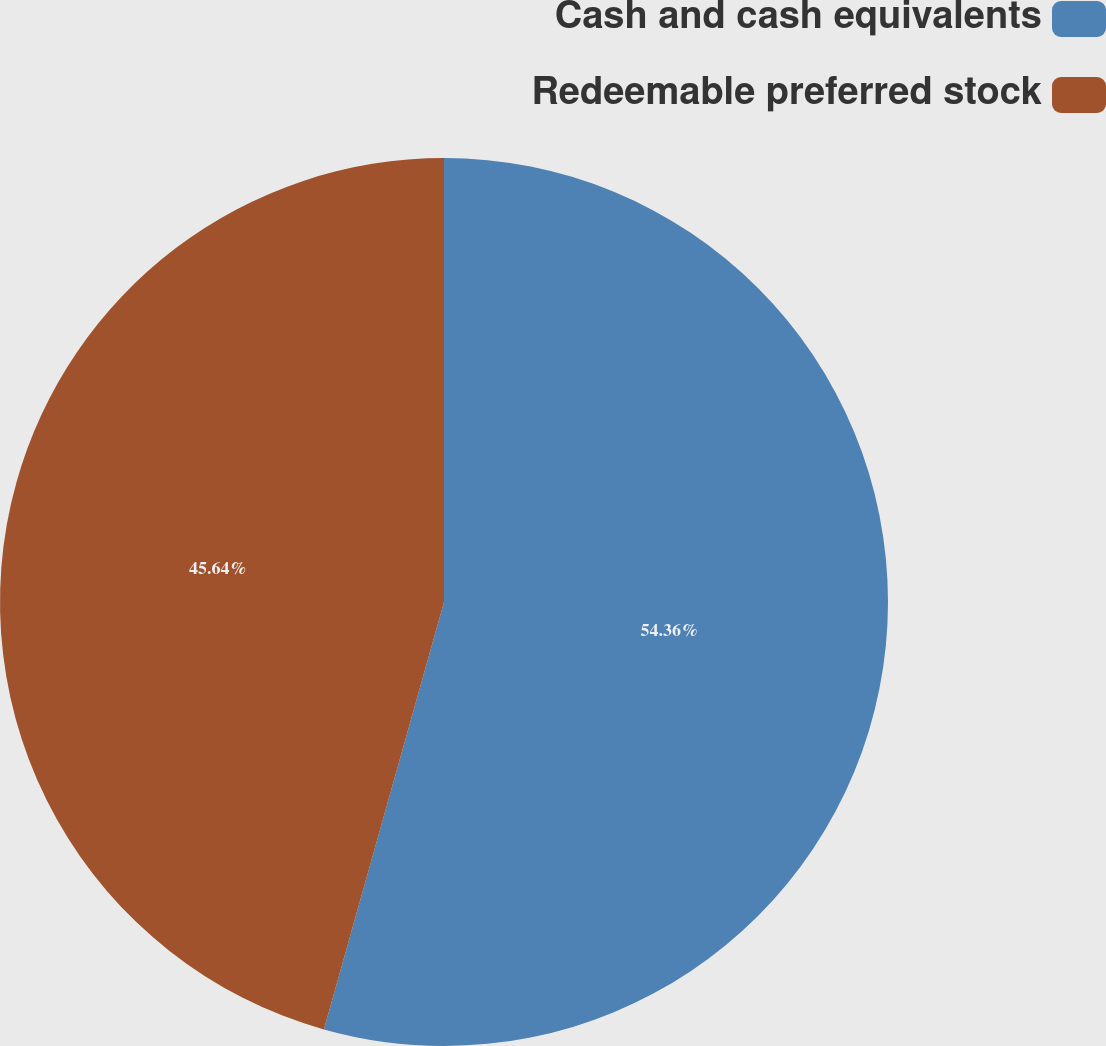Convert chart. <chart><loc_0><loc_0><loc_500><loc_500><pie_chart><fcel>Cash and cash equivalents<fcel>Redeemable preferred stock<nl><fcel>54.36%<fcel>45.64%<nl></chart> 